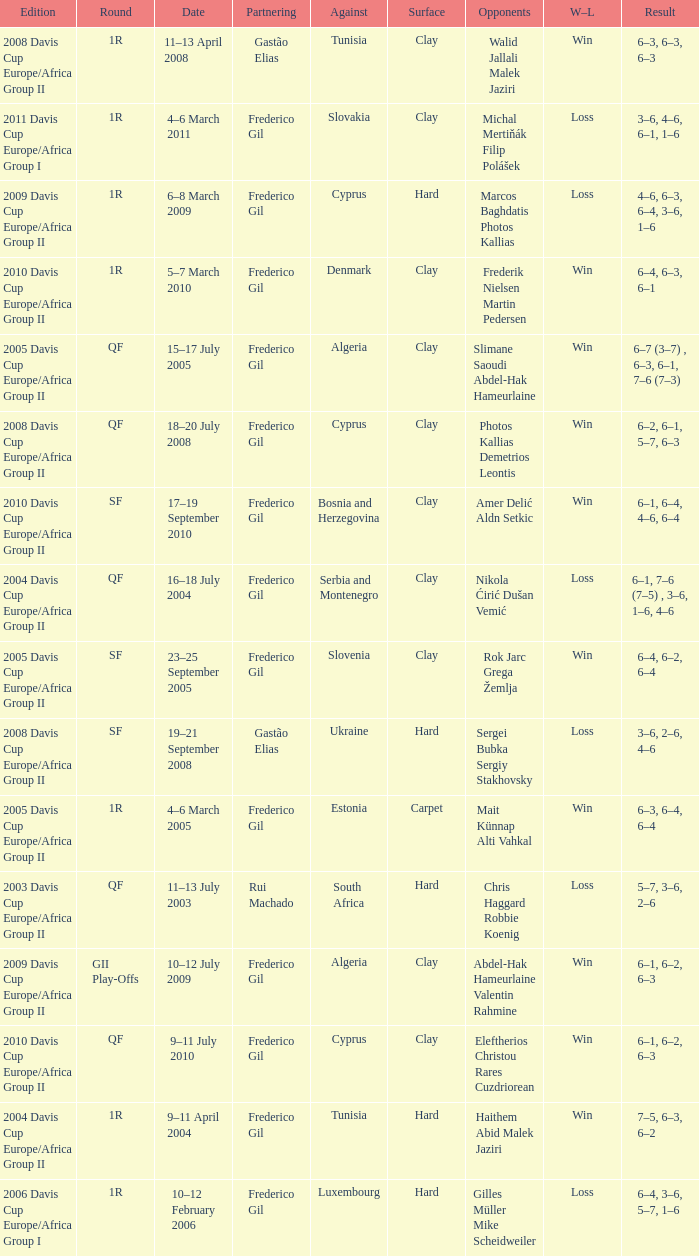How many rounds were there in the 2006 davis cup europe/africa group I? 1.0. 